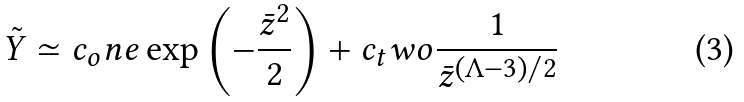Convert formula to latex. <formula><loc_0><loc_0><loc_500><loc_500>\tilde { Y } \simeq c _ { o } n e \exp \left ( - \frac { \bar { z } ^ { 2 } } { 2 } \right ) + c _ { t } w o \frac { 1 } { \bar { z } ^ { ( \Lambda - 3 ) / 2 } }</formula> 